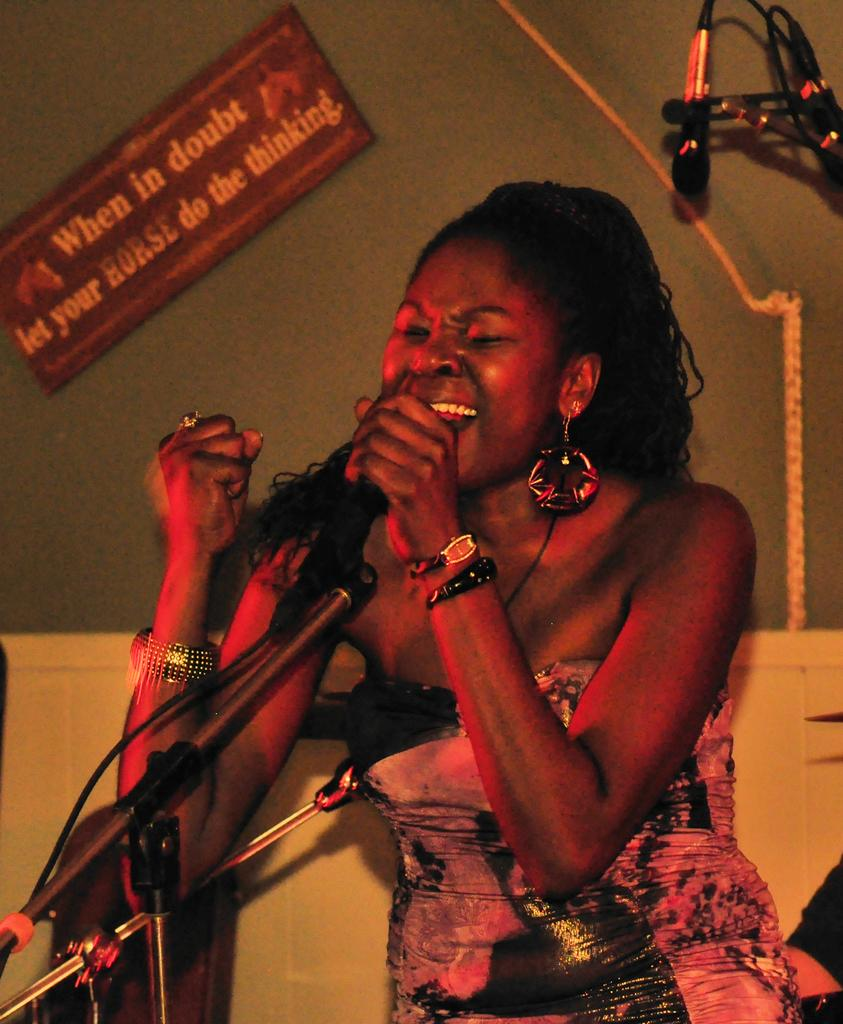Who is present in the image? There is a woman in the image. What is the woman doing in the image? The woman is standing and holding a microphone. What can be seen on the wall in the image? There is a board on the wall in the image. What type of jellyfish can be seen swimming near the woman in the image? There are no jellyfish present in the image; it features a woman standing and holding a microphone. What statement is the woman making into the microphone in the image? The image does not provide any information about the statement the woman might be making into the microphone. 